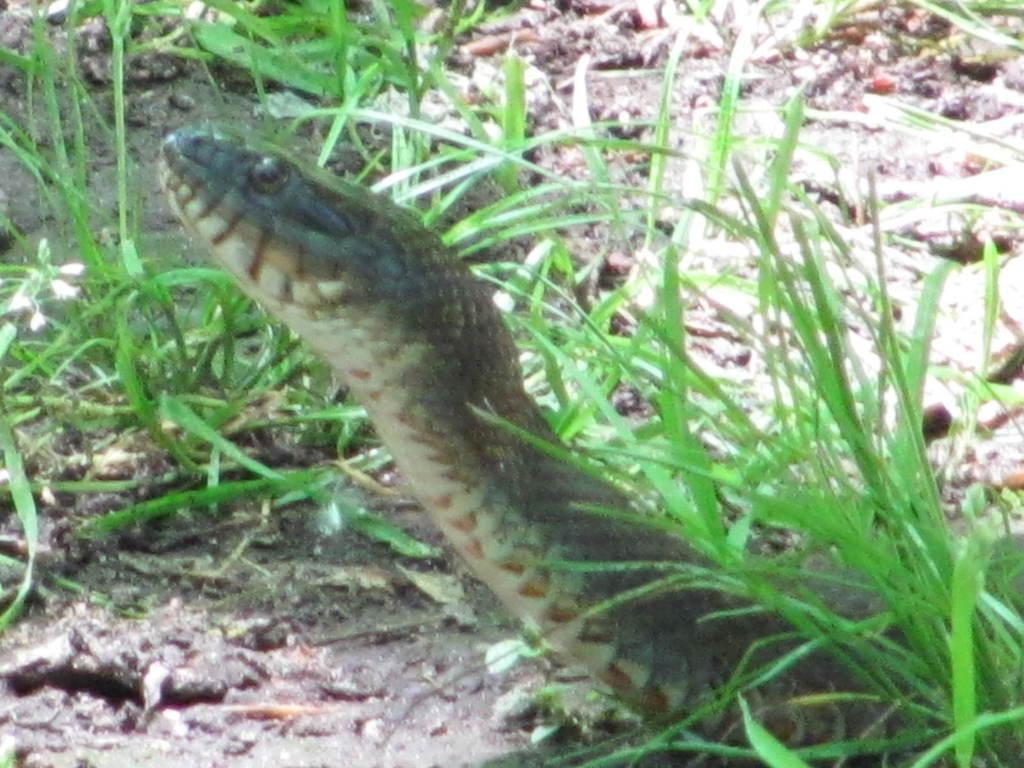In one or two sentences, can you explain what this image depicts? In this picture there is a snake on the ground, beside him i can see the green grass. 